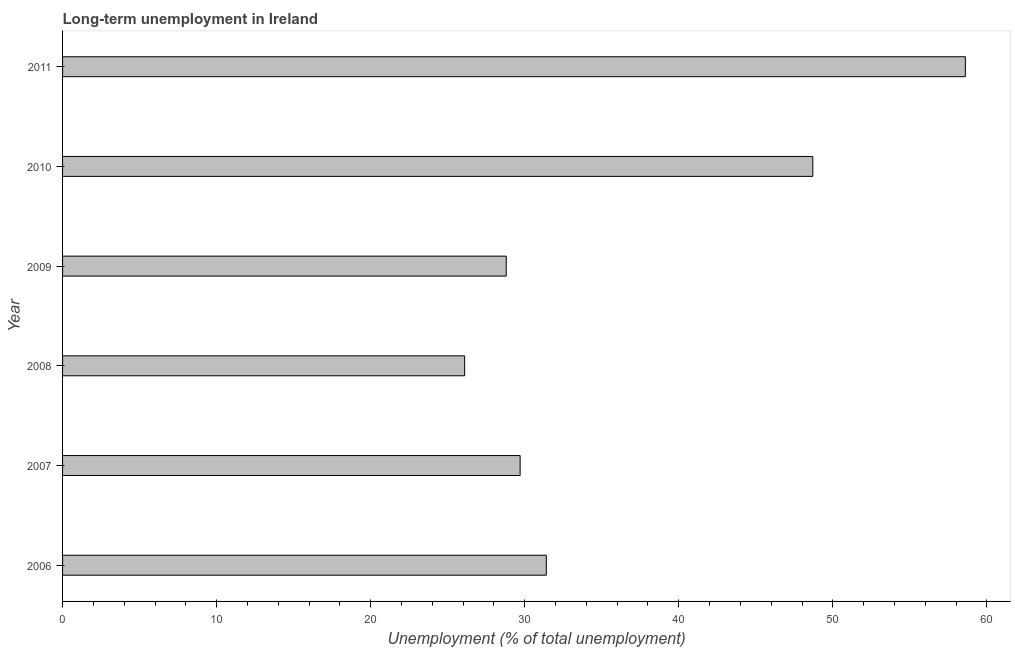What is the title of the graph?
Ensure brevity in your answer.  Long-term unemployment in Ireland. What is the label or title of the X-axis?
Offer a very short reply. Unemployment (% of total unemployment). What is the label or title of the Y-axis?
Your answer should be very brief. Year. What is the long-term unemployment in 2007?
Make the answer very short. 29.7. Across all years, what is the maximum long-term unemployment?
Make the answer very short. 58.6. Across all years, what is the minimum long-term unemployment?
Offer a terse response. 26.1. What is the sum of the long-term unemployment?
Your response must be concise. 223.3. What is the difference between the long-term unemployment in 2010 and 2011?
Ensure brevity in your answer.  -9.9. What is the average long-term unemployment per year?
Make the answer very short. 37.22. What is the median long-term unemployment?
Give a very brief answer. 30.55. In how many years, is the long-term unemployment greater than 38 %?
Provide a succinct answer. 2. Do a majority of the years between 2006 and 2007 (inclusive) have long-term unemployment greater than 48 %?
Offer a terse response. No. What is the ratio of the long-term unemployment in 2006 to that in 2007?
Provide a short and direct response. 1.06. Is the long-term unemployment in 2008 less than that in 2011?
Offer a very short reply. Yes. What is the difference between the highest and the second highest long-term unemployment?
Make the answer very short. 9.9. What is the difference between the highest and the lowest long-term unemployment?
Ensure brevity in your answer.  32.5. In how many years, is the long-term unemployment greater than the average long-term unemployment taken over all years?
Offer a very short reply. 2. How many bars are there?
Your answer should be very brief. 6. Are all the bars in the graph horizontal?
Keep it short and to the point. Yes. What is the difference between two consecutive major ticks on the X-axis?
Your answer should be compact. 10. Are the values on the major ticks of X-axis written in scientific E-notation?
Ensure brevity in your answer.  No. What is the Unemployment (% of total unemployment) in 2006?
Ensure brevity in your answer.  31.4. What is the Unemployment (% of total unemployment) of 2007?
Make the answer very short. 29.7. What is the Unemployment (% of total unemployment) of 2008?
Provide a short and direct response. 26.1. What is the Unemployment (% of total unemployment) of 2009?
Keep it short and to the point. 28.8. What is the Unemployment (% of total unemployment) of 2010?
Give a very brief answer. 48.7. What is the Unemployment (% of total unemployment) of 2011?
Ensure brevity in your answer.  58.6. What is the difference between the Unemployment (% of total unemployment) in 2006 and 2007?
Offer a terse response. 1.7. What is the difference between the Unemployment (% of total unemployment) in 2006 and 2008?
Ensure brevity in your answer.  5.3. What is the difference between the Unemployment (% of total unemployment) in 2006 and 2009?
Make the answer very short. 2.6. What is the difference between the Unemployment (% of total unemployment) in 2006 and 2010?
Make the answer very short. -17.3. What is the difference between the Unemployment (% of total unemployment) in 2006 and 2011?
Your answer should be compact. -27.2. What is the difference between the Unemployment (% of total unemployment) in 2007 and 2008?
Make the answer very short. 3.6. What is the difference between the Unemployment (% of total unemployment) in 2007 and 2010?
Give a very brief answer. -19. What is the difference between the Unemployment (% of total unemployment) in 2007 and 2011?
Your response must be concise. -28.9. What is the difference between the Unemployment (% of total unemployment) in 2008 and 2010?
Ensure brevity in your answer.  -22.6. What is the difference between the Unemployment (% of total unemployment) in 2008 and 2011?
Provide a short and direct response. -32.5. What is the difference between the Unemployment (% of total unemployment) in 2009 and 2010?
Ensure brevity in your answer.  -19.9. What is the difference between the Unemployment (% of total unemployment) in 2009 and 2011?
Provide a succinct answer. -29.8. What is the difference between the Unemployment (% of total unemployment) in 2010 and 2011?
Your answer should be very brief. -9.9. What is the ratio of the Unemployment (% of total unemployment) in 2006 to that in 2007?
Offer a very short reply. 1.06. What is the ratio of the Unemployment (% of total unemployment) in 2006 to that in 2008?
Your response must be concise. 1.2. What is the ratio of the Unemployment (% of total unemployment) in 2006 to that in 2009?
Your answer should be very brief. 1.09. What is the ratio of the Unemployment (% of total unemployment) in 2006 to that in 2010?
Your answer should be very brief. 0.65. What is the ratio of the Unemployment (% of total unemployment) in 2006 to that in 2011?
Keep it short and to the point. 0.54. What is the ratio of the Unemployment (% of total unemployment) in 2007 to that in 2008?
Give a very brief answer. 1.14. What is the ratio of the Unemployment (% of total unemployment) in 2007 to that in 2009?
Provide a succinct answer. 1.03. What is the ratio of the Unemployment (% of total unemployment) in 2007 to that in 2010?
Your answer should be very brief. 0.61. What is the ratio of the Unemployment (% of total unemployment) in 2007 to that in 2011?
Your response must be concise. 0.51. What is the ratio of the Unemployment (% of total unemployment) in 2008 to that in 2009?
Your response must be concise. 0.91. What is the ratio of the Unemployment (% of total unemployment) in 2008 to that in 2010?
Provide a succinct answer. 0.54. What is the ratio of the Unemployment (% of total unemployment) in 2008 to that in 2011?
Keep it short and to the point. 0.45. What is the ratio of the Unemployment (% of total unemployment) in 2009 to that in 2010?
Your response must be concise. 0.59. What is the ratio of the Unemployment (% of total unemployment) in 2009 to that in 2011?
Your answer should be very brief. 0.49. What is the ratio of the Unemployment (% of total unemployment) in 2010 to that in 2011?
Ensure brevity in your answer.  0.83. 